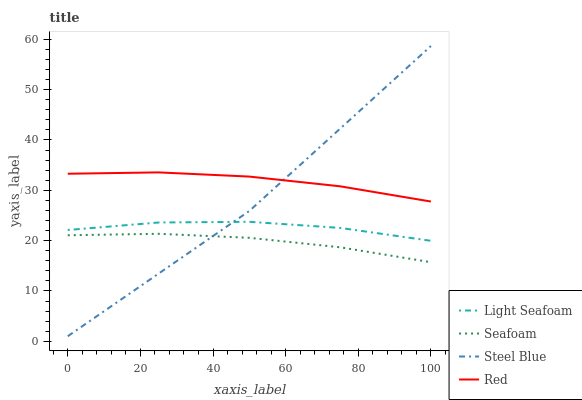Does Seafoam have the minimum area under the curve?
Answer yes or no. Yes. Does Red have the maximum area under the curve?
Answer yes or no. Yes. Does Red have the minimum area under the curve?
Answer yes or no. No. Does Seafoam have the maximum area under the curve?
Answer yes or no. No. Is Seafoam the smoothest?
Answer yes or no. Yes. Is Light Seafoam the roughest?
Answer yes or no. Yes. Is Red the smoothest?
Answer yes or no. No. Is Red the roughest?
Answer yes or no. No. Does Seafoam have the lowest value?
Answer yes or no. No. Does Steel Blue have the highest value?
Answer yes or no. Yes. Does Red have the highest value?
Answer yes or no. No. Is Seafoam less than Light Seafoam?
Answer yes or no. Yes. Is Red greater than Seafoam?
Answer yes or no. Yes. Does Red intersect Steel Blue?
Answer yes or no. Yes. Is Red less than Steel Blue?
Answer yes or no. No. Is Red greater than Steel Blue?
Answer yes or no. No. Does Seafoam intersect Light Seafoam?
Answer yes or no. No. 